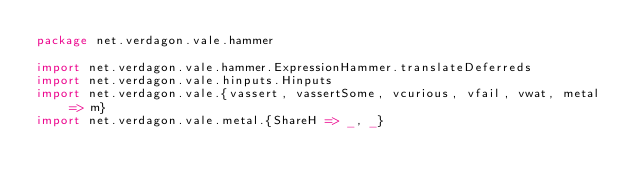Convert code to text. <code><loc_0><loc_0><loc_500><loc_500><_Scala_>package net.verdagon.vale.hammer

import net.verdagon.vale.hammer.ExpressionHammer.translateDeferreds
import net.verdagon.vale.hinputs.Hinputs
import net.verdagon.vale.{vassert, vassertSome, vcurious, vfail, vwat, metal => m}
import net.verdagon.vale.metal.{ShareH => _, _}</code> 